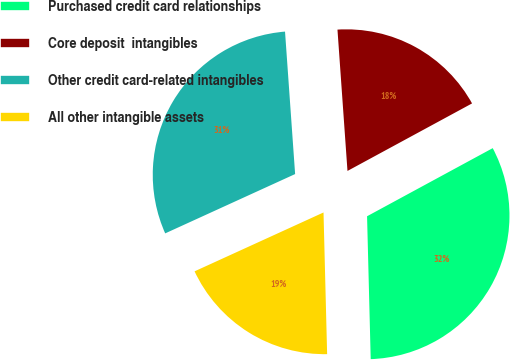Convert chart. <chart><loc_0><loc_0><loc_500><loc_500><pie_chart><fcel>Purchased credit card relationships<fcel>Core deposit  intangibles<fcel>Other credit card-related intangibles<fcel>All other intangible assets<nl><fcel>32.5%<fcel>18.22%<fcel>30.69%<fcel>18.59%<nl></chart> 